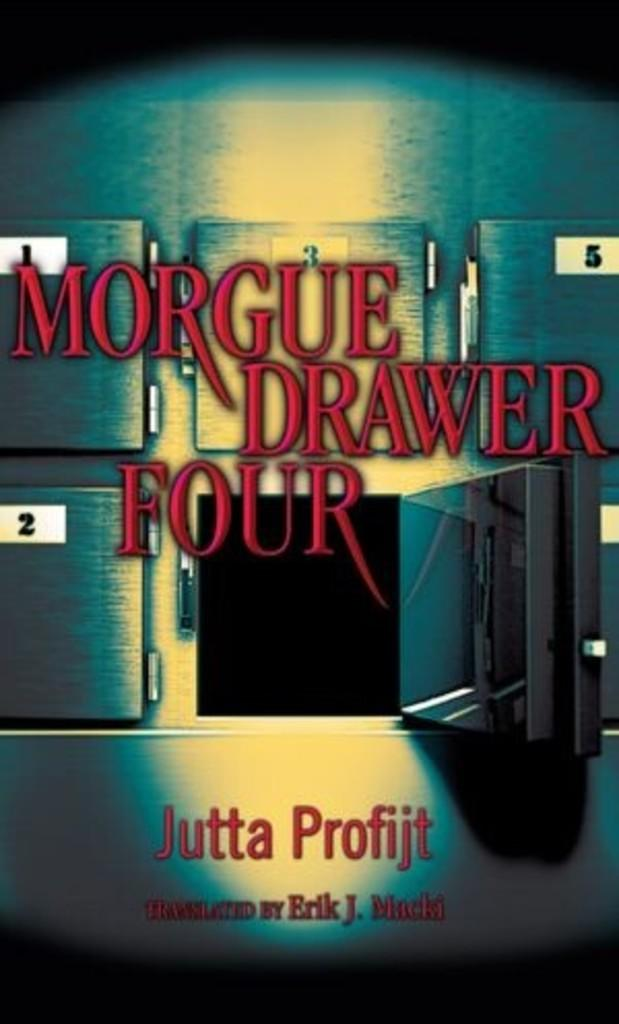Provide a one-sentence caption for the provided image. The picture shows a morgue in particular the opened drawer four. 